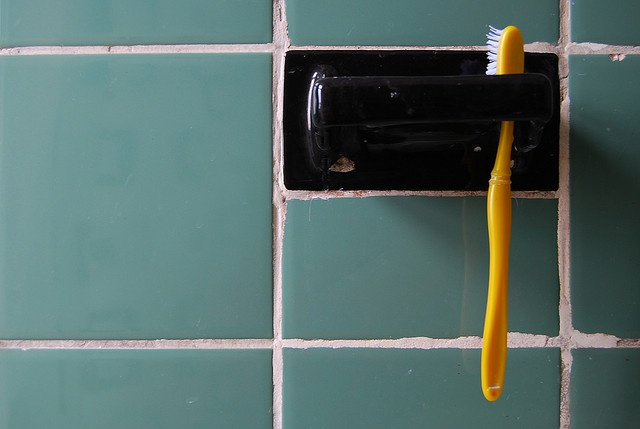Describe the objects in this image and their specific colors. I can see a toothbrush in darkgray, brown, orange, black, and maroon tones in this image. 